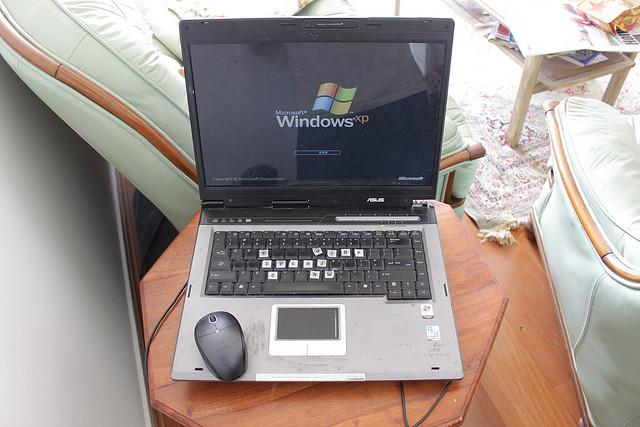How many people are in this photo?
Give a very brief answer. 0. What color is the laptop?
Short answer required. Silver. What operating system is installed on the laptop?
Quick response, please. Windows xp. 